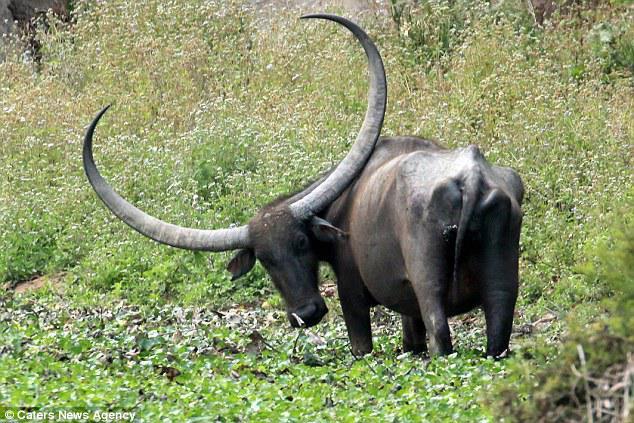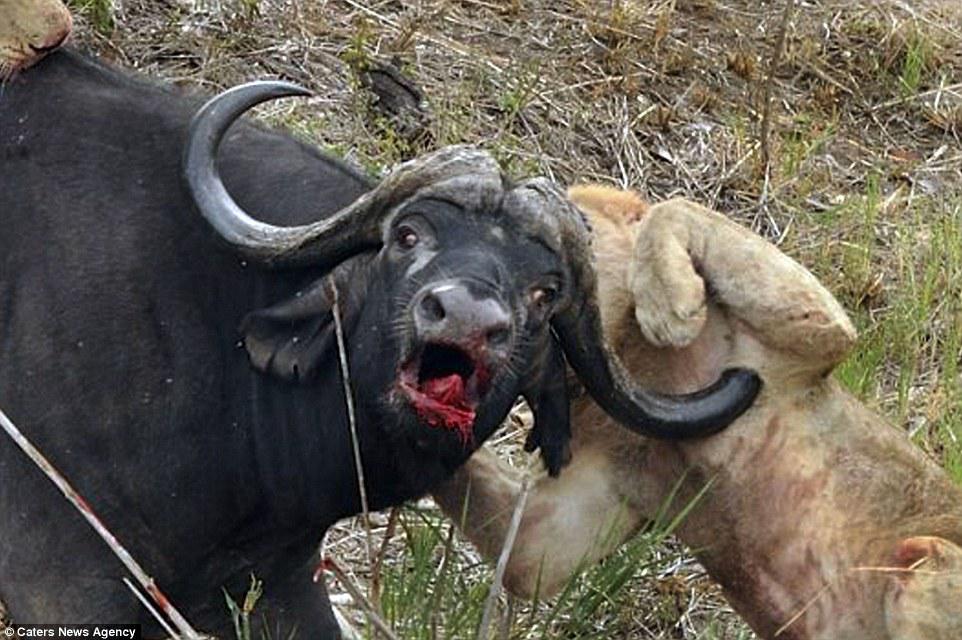The first image is the image on the left, the second image is the image on the right. Examine the images to the left and right. Is the description "The animal in the image on the left is turned directly toward the camera" accurate? Answer yes or no. No. The first image is the image on the left, the second image is the image on the right. For the images shown, is this caption "There is an animal that is not an ox in at least one image." true? Answer yes or no. Yes. The first image is the image on the left, the second image is the image on the right. Evaluate the accuracy of this statement regarding the images: "Every animal has horns and none has a bird on its head.". Is it true? Answer yes or no. No. 